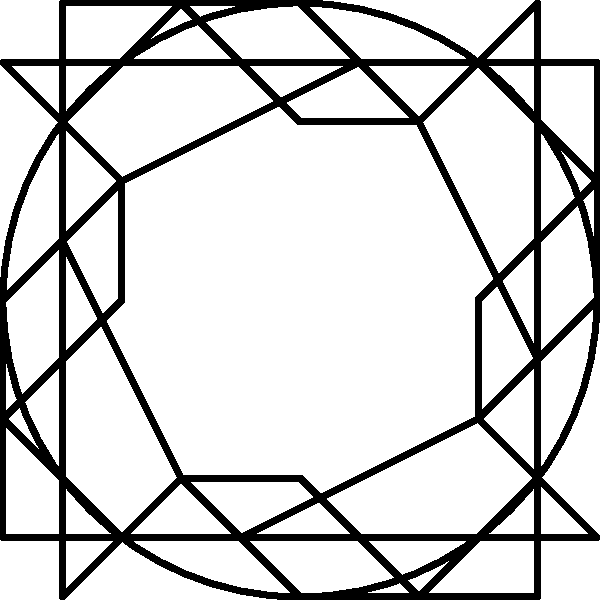Consider the social justice symbol shown above, which features four raised fists arranged in a circular pattern. What is the order of rotational symmetry for this symbol? To determine the order of rotational symmetry, we need to follow these steps:

1. Identify the center of rotation: In this case, it's the center of the circular arrangement.

2. Determine how many times the symbol can be rotated to produce an identical configuration:
   - A 90° rotation (quarter turn) results in an identical arrangement.
   - A 180° rotation (half turn) also results in an identical arrangement.
   - A 270° rotation (three-quarter turn) results in an identical arrangement.
   - A 360° rotation (full turn) brings us back to the original position.

3. Count the number of rotations (including the original position) that result in an identical configuration:
   - 0° (original position)
   - 90°
   - 180°
   - 270°

4. The total number of these rotations is 4, which is the order of rotational symmetry.

In group theory terms, this symbol exhibits $C_4$ symmetry, where $C_4$ represents the cyclic group of order 4.
Answer: 4 